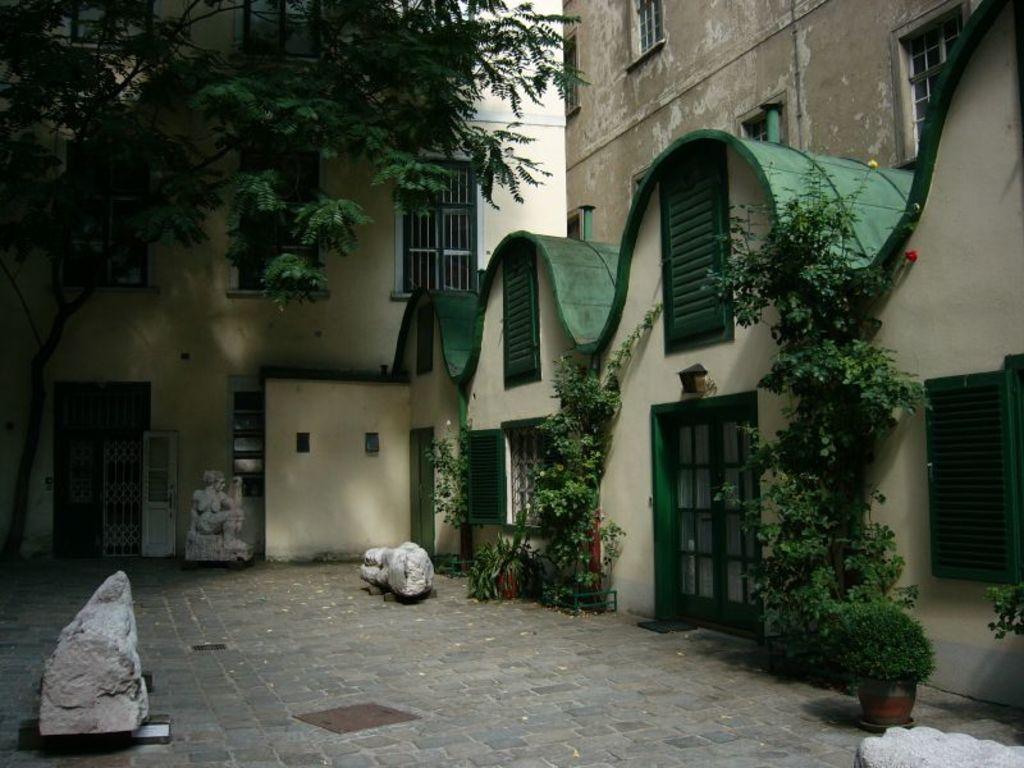Can you describe this image briefly? In this picture I can see there are few statues here and there are plants and buildings and there are windows and doors. 